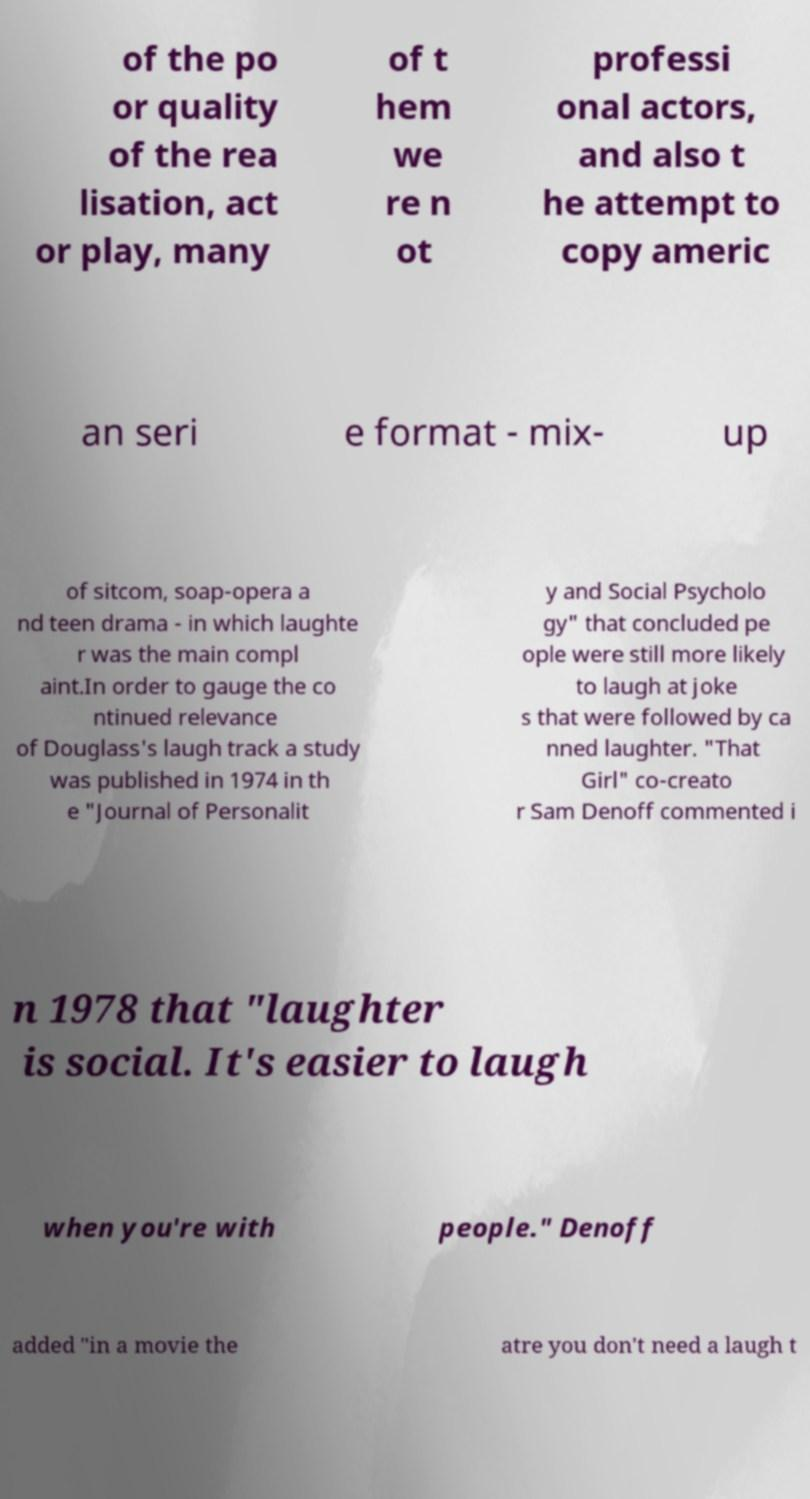I need the written content from this picture converted into text. Can you do that? of the po or quality of the rea lisation, act or play, many of t hem we re n ot professi onal actors, and also t he attempt to copy americ an seri e format - mix- up of sitcom, soap-opera a nd teen drama - in which laughte r was the main compl aint.In order to gauge the co ntinued relevance of Douglass's laugh track a study was published in 1974 in th e "Journal of Personalit y and Social Psycholo gy" that concluded pe ople were still more likely to laugh at joke s that were followed by ca nned laughter. "That Girl" co-creato r Sam Denoff commented i n 1978 that "laughter is social. It's easier to laugh when you're with people." Denoff added "in a movie the atre you don't need a laugh t 